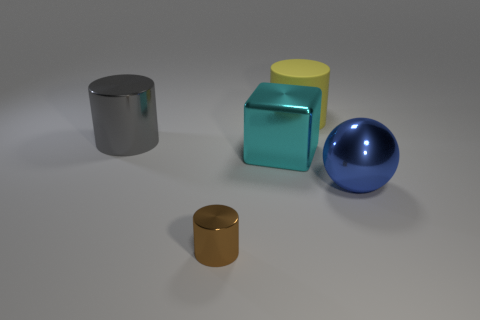Is there any other thing that is the same material as the big yellow thing?
Your answer should be compact. No. Does the brown thing have the same shape as the large yellow thing?
Provide a succinct answer. Yes. What number of other objects are there of the same size as the matte thing?
Keep it short and to the point. 3. What number of objects are large things that are behind the gray shiny cylinder or things to the right of the small brown metallic cylinder?
Provide a succinct answer. 3. How many large cyan things have the same shape as the brown thing?
Make the answer very short. 0. The thing that is behind the cyan block and in front of the big matte cylinder is made of what material?
Provide a short and direct response. Metal. How many big yellow rubber things are right of the big blue metal ball?
Provide a succinct answer. 0. What number of cyan shiny blocks are there?
Your response must be concise. 1. Does the brown object have the same size as the cyan shiny thing?
Your answer should be compact. No. There is a shiny cylinder that is right of the shiny cylinder that is behind the blue metallic sphere; are there any metal cylinders behind it?
Ensure brevity in your answer.  Yes. 